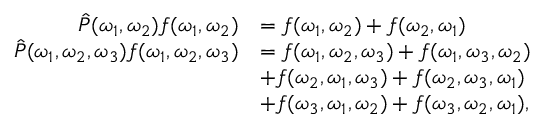Convert formula to latex. <formula><loc_0><loc_0><loc_500><loc_500>\begin{array} { r l } { \hat { P } ( \omega _ { 1 } , \omega _ { 2 } ) f ( \omega _ { 1 } , \omega _ { 2 } ) } & { = f ( \omega _ { 1 } , \omega _ { 2 } ) + f ( \omega _ { 2 } , \omega _ { 1 } ) } \\ { \hat { P } ( \omega _ { 1 } , \omega _ { 2 } , \omega _ { 3 } ) f ( \omega _ { 1 } , \omega _ { 2 } , \omega _ { 3 } ) } & { = f ( \omega _ { 1 } , \omega _ { 2 } , \omega _ { 3 } ) + f ( \omega _ { 1 } , \omega _ { 3 } , \omega _ { 2 } ) } \\ & { + f ( \omega _ { 2 } , \omega _ { 1 } , \omega _ { 3 } ) + f ( \omega _ { 2 } , \omega _ { 3 } , \omega _ { 1 } ) } \\ & { + f ( \omega _ { 3 } , \omega _ { 1 } , \omega _ { 2 } ) + f ( \omega _ { 3 } , \omega _ { 2 } , \omega _ { 1 } ) , } \end{array}</formula> 